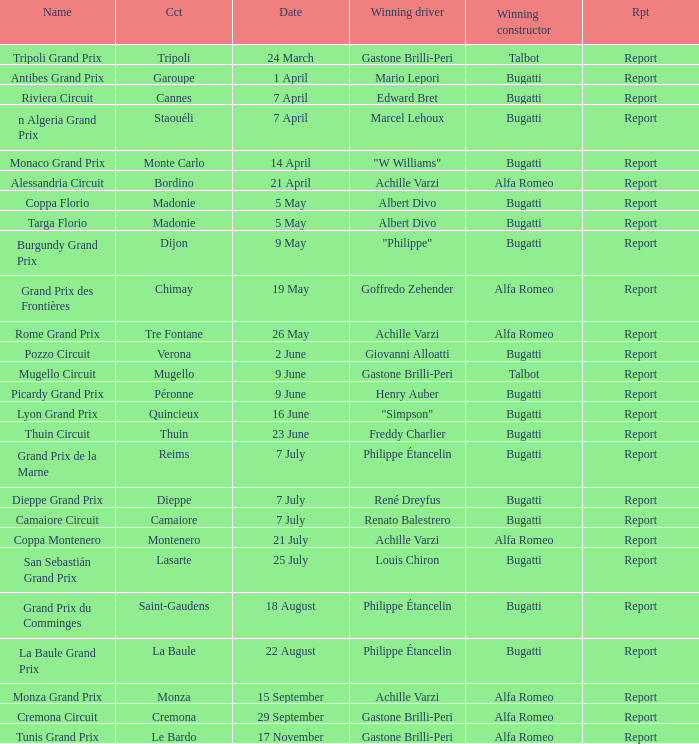Parse the table in full. {'header': ['Name', 'Cct', 'Date', 'Winning driver', 'Winning constructor', 'Rpt'], 'rows': [['Tripoli Grand Prix', 'Tripoli', '24 March', 'Gastone Brilli-Peri', 'Talbot', 'Report'], ['Antibes Grand Prix', 'Garoupe', '1 April', 'Mario Lepori', 'Bugatti', 'Report'], ['Riviera Circuit', 'Cannes', '7 April', 'Edward Bret', 'Bugatti', 'Report'], ['n Algeria Grand Prix', 'Staouéli', '7 April', 'Marcel Lehoux', 'Bugatti', 'Report'], ['Monaco Grand Prix', 'Monte Carlo', '14 April', '"W Williams"', 'Bugatti', 'Report'], ['Alessandria Circuit', 'Bordino', '21 April', 'Achille Varzi', 'Alfa Romeo', 'Report'], ['Coppa Florio', 'Madonie', '5 May', 'Albert Divo', 'Bugatti', 'Report'], ['Targa Florio', 'Madonie', '5 May', 'Albert Divo', 'Bugatti', 'Report'], ['Burgundy Grand Prix', 'Dijon', '9 May', '"Philippe"', 'Bugatti', 'Report'], ['Grand Prix des Frontières', 'Chimay', '19 May', 'Goffredo Zehender', 'Alfa Romeo', 'Report'], ['Rome Grand Prix', 'Tre Fontane', '26 May', 'Achille Varzi', 'Alfa Romeo', 'Report'], ['Pozzo Circuit', 'Verona', '2 June', 'Giovanni Alloatti', 'Bugatti', 'Report'], ['Mugello Circuit', 'Mugello', '9 June', 'Gastone Brilli-Peri', 'Talbot', 'Report'], ['Picardy Grand Prix', 'Péronne', '9 June', 'Henry Auber', 'Bugatti', 'Report'], ['Lyon Grand Prix', 'Quincieux', '16 June', '"Simpson"', 'Bugatti', 'Report'], ['Thuin Circuit', 'Thuin', '23 June', 'Freddy Charlier', 'Bugatti', 'Report'], ['Grand Prix de la Marne', 'Reims', '7 July', 'Philippe Étancelin', 'Bugatti', 'Report'], ['Dieppe Grand Prix', 'Dieppe', '7 July', 'René Dreyfus', 'Bugatti', 'Report'], ['Camaiore Circuit', 'Camaiore', '7 July', 'Renato Balestrero', 'Bugatti', 'Report'], ['Coppa Montenero', 'Montenero', '21 July', 'Achille Varzi', 'Alfa Romeo', 'Report'], ['San Sebastián Grand Prix', 'Lasarte', '25 July', 'Louis Chiron', 'Bugatti', 'Report'], ['Grand Prix du Comminges', 'Saint-Gaudens', '18 August', 'Philippe Étancelin', 'Bugatti', 'Report'], ['La Baule Grand Prix', 'La Baule', '22 August', 'Philippe Étancelin', 'Bugatti', 'Report'], ['Monza Grand Prix', 'Monza', '15 September', 'Achille Varzi', 'Alfa Romeo', 'Report'], ['Cremona Circuit', 'Cremona', '29 September', 'Gastone Brilli-Peri', 'Alfa Romeo', 'Report'], ['Tunis Grand Prix', 'Le Bardo', '17 November', 'Gastone Brilli-Peri', 'Alfa Romeo', 'Report']]} What Winning driver has a Name of mugello circuit? Gastone Brilli-Peri. 